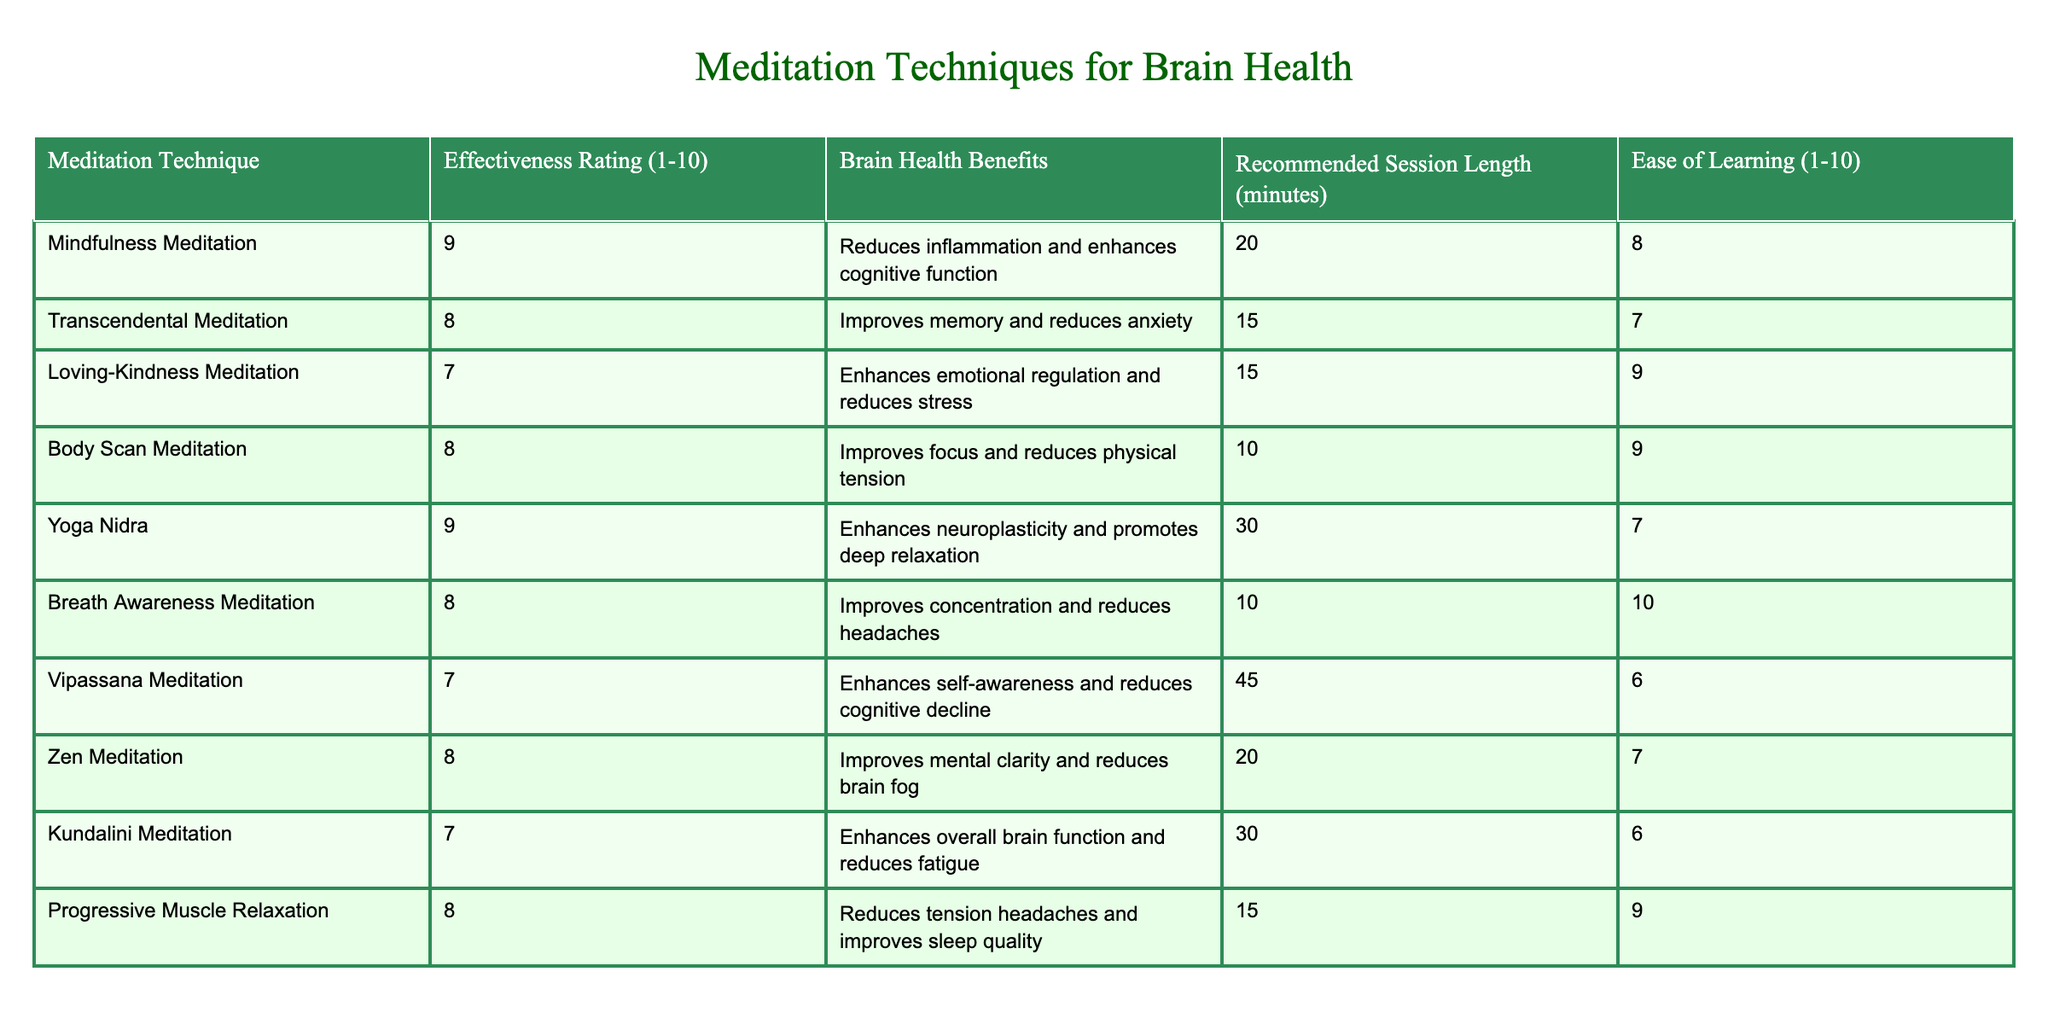What is the effectiveness rating of Mindfulness Meditation? Mindfulness Meditation has an effectiveness rating of 9 as stated directly in the table.
Answer: 9 How many meditation techniques have an effectiveness rating of 8? The table lists five techniques with an effectiveness rating of 8: Transcendental Meditation, Body Scan Meditation, Breath Awareness Meditation, Zen Meditation, and Progressive Muscle Relaxation.
Answer: 5 Which meditation technique has the highest ease of learning? The technique with the highest ease of learning is Breath Awareness Meditation, which has a rating of 10. This is clearly indicated in the table.
Answer: Breath Awareness Meditation What is the average recommended session length for techniques with an effectiveness rating of 7? The techniques with a rating of 7 are Loving-Kindness Meditation, Vipassana Meditation, and Kundalini Meditation. Their session lengths are 15, 45, and 30 minutes respectively. The average is (15 + 45 + 30) / 3 = 30 minutes.
Answer: 30 minutes True or False: Yoga Nidra is listed as having a lower effectiveness rating than Loving-Kindness Meditation. Yoga Nidra has an effectiveness rating of 9, while Loving-Kindness Meditation has a rating of 7. Therefore, the statement is False.
Answer: False What are the brain health benefits of yoga nidra? The table indicates that Yoga Nidra enhances neuroplasticity and promotes deep relaxation.
Answer: Enhances neuroplasticity and promotes deep relaxation Which meditation technique has the shortest recommended session length and what is its effectiveness rating? The meditation technique with the shortest session length is Body Scan Meditation, which is recommended for 10 minutes and has an effectiveness rating of 8.
Answer: Body Scan Meditation, Effectiveness Rating: 8 How does the effectiveness rating of Transcendental Meditation compare to that of Zen Meditation? Transcendental Meditation has an effectiveness rating of 8, while Zen Meditation also has an effectiveness rating of 8. Therefore, they are equal in effectiveness rating.
Answer: They are equal (both are 8) What is the total number of techniques that have brain health benefits related to stress reduction? The techniques that reduce stress are Loving-Kindness Meditation, Body Scan Meditation, and Progressive Muscle Relaxation. There are three techniques in total that fit this criterion.
Answer: 3 